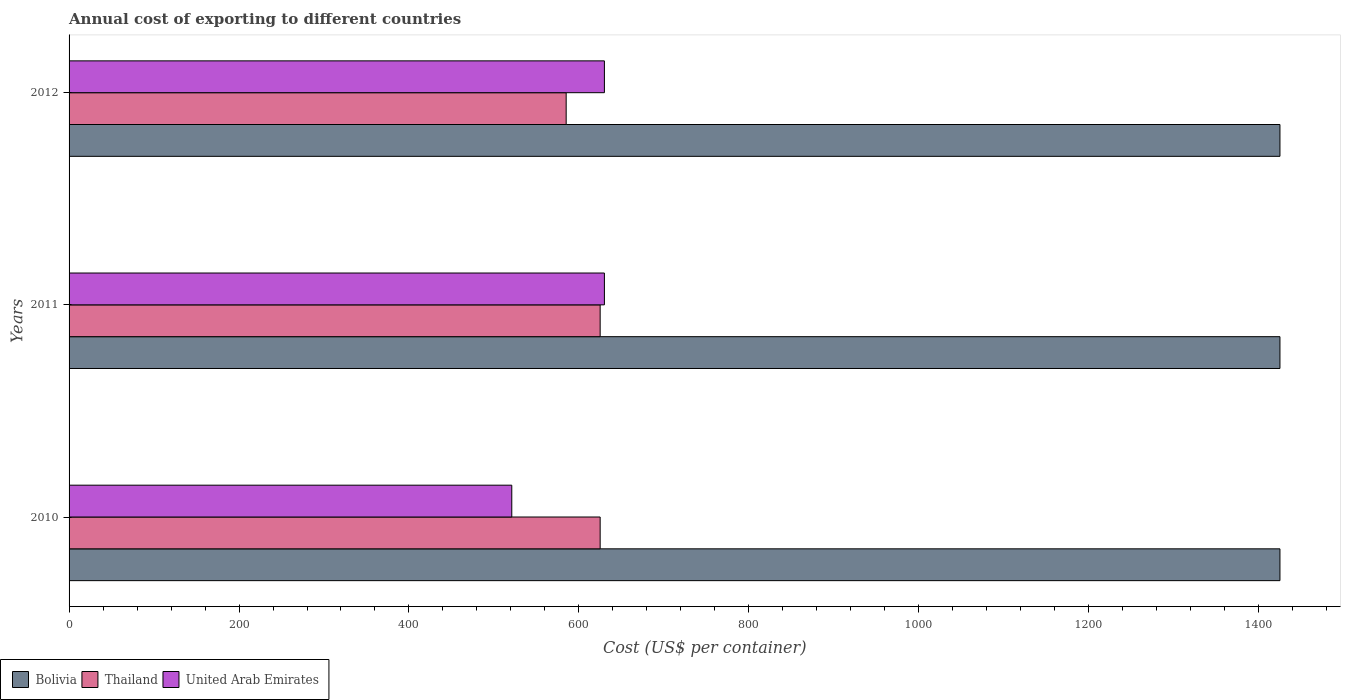How many groups of bars are there?
Keep it short and to the point. 3. Are the number of bars per tick equal to the number of legend labels?
Keep it short and to the point. Yes. How many bars are there on the 3rd tick from the top?
Offer a terse response. 3. How many bars are there on the 2nd tick from the bottom?
Your answer should be very brief. 3. In how many cases, is the number of bars for a given year not equal to the number of legend labels?
Your response must be concise. 0. What is the total annual cost of exporting in Bolivia in 2010?
Your response must be concise. 1425. Across all years, what is the maximum total annual cost of exporting in United Arab Emirates?
Give a very brief answer. 630. Across all years, what is the minimum total annual cost of exporting in Thailand?
Your answer should be compact. 585. In which year was the total annual cost of exporting in Bolivia maximum?
Offer a terse response. 2010. In which year was the total annual cost of exporting in Bolivia minimum?
Ensure brevity in your answer.  2010. What is the total total annual cost of exporting in Thailand in the graph?
Give a very brief answer. 1835. What is the difference between the total annual cost of exporting in Thailand in 2011 and that in 2012?
Your answer should be compact. 40. What is the difference between the total annual cost of exporting in United Arab Emirates in 2011 and the total annual cost of exporting in Thailand in 2012?
Your answer should be compact. 45. What is the average total annual cost of exporting in Bolivia per year?
Provide a short and direct response. 1425. In the year 2010, what is the difference between the total annual cost of exporting in Thailand and total annual cost of exporting in Bolivia?
Your response must be concise. -800. What is the difference between the highest and the lowest total annual cost of exporting in United Arab Emirates?
Keep it short and to the point. 109. In how many years, is the total annual cost of exporting in Thailand greater than the average total annual cost of exporting in Thailand taken over all years?
Your response must be concise. 2. Is the sum of the total annual cost of exporting in Bolivia in 2010 and 2011 greater than the maximum total annual cost of exporting in Thailand across all years?
Make the answer very short. Yes. What does the 2nd bar from the top in 2011 represents?
Your answer should be compact. Thailand. What does the 2nd bar from the bottom in 2012 represents?
Give a very brief answer. Thailand. How many years are there in the graph?
Your answer should be very brief. 3. What is the difference between two consecutive major ticks on the X-axis?
Your answer should be compact. 200. Does the graph contain grids?
Ensure brevity in your answer.  No. What is the title of the graph?
Provide a short and direct response. Annual cost of exporting to different countries. What is the label or title of the X-axis?
Keep it short and to the point. Cost (US$ per container). What is the label or title of the Y-axis?
Offer a very short reply. Years. What is the Cost (US$ per container) of Bolivia in 2010?
Ensure brevity in your answer.  1425. What is the Cost (US$ per container) in Thailand in 2010?
Offer a terse response. 625. What is the Cost (US$ per container) of United Arab Emirates in 2010?
Offer a very short reply. 521. What is the Cost (US$ per container) of Bolivia in 2011?
Offer a terse response. 1425. What is the Cost (US$ per container) in Thailand in 2011?
Your answer should be very brief. 625. What is the Cost (US$ per container) of United Arab Emirates in 2011?
Make the answer very short. 630. What is the Cost (US$ per container) of Bolivia in 2012?
Offer a terse response. 1425. What is the Cost (US$ per container) of Thailand in 2012?
Ensure brevity in your answer.  585. What is the Cost (US$ per container) of United Arab Emirates in 2012?
Offer a terse response. 630. Across all years, what is the maximum Cost (US$ per container) of Bolivia?
Your response must be concise. 1425. Across all years, what is the maximum Cost (US$ per container) in Thailand?
Ensure brevity in your answer.  625. Across all years, what is the maximum Cost (US$ per container) of United Arab Emirates?
Provide a short and direct response. 630. Across all years, what is the minimum Cost (US$ per container) of Bolivia?
Give a very brief answer. 1425. Across all years, what is the minimum Cost (US$ per container) in Thailand?
Give a very brief answer. 585. Across all years, what is the minimum Cost (US$ per container) in United Arab Emirates?
Offer a very short reply. 521. What is the total Cost (US$ per container) of Bolivia in the graph?
Ensure brevity in your answer.  4275. What is the total Cost (US$ per container) of Thailand in the graph?
Provide a short and direct response. 1835. What is the total Cost (US$ per container) of United Arab Emirates in the graph?
Provide a succinct answer. 1781. What is the difference between the Cost (US$ per container) of Bolivia in 2010 and that in 2011?
Provide a succinct answer. 0. What is the difference between the Cost (US$ per container) of Thailand in 2010 and that in 2011?
Offer a very short reply. 0. What is the difference between the Cost (US$ per container) in United Arab Emirates in 2010 and that in 2011?
Give a very brief answer. -109. What is the difference between the Cost (US$ per container) in United Arab Emirates in 2010 and that in 2012?
Make the answer very short. -109. What is the difference between the Cost (US$ per container) of Thailand in 2011 and that in 2012?
Make the answer very short. 40. What is the difference between the Cost (US$ per container) of United Arab Emirates in 2011 and that in 2012?
Make the answer very short. 0. What is the difference between the Cost (US$ per container) of Bolivia in 2010 and the Cost (US$ per container) of Thailand in 2011?
Keep it short and to the point. 800. What is the difference between the Cost (US$ per container) in Bolivia in 2010 and the Cost (US$ per container) in United Arab Emirates in 2011?
Your response must be concise. 795. What is the difference between the Cost (US$ per container) of Thailand in 2010 and the Cost (US$ per container) of United Arab Emirates in 2011?
Your answer should be very brief. -5. What is the difference between the Cost (US$ per container) of Bolivia in 2010 and the Cost (US$ per container) of Thailand in 2012?
Ensure brevity in your answer.  840. What is the difference between the Cost (US$ per container) in Bolivia in 2010 and the Cost (US$ per container) in United Arab Emirates in 2012?
Give a very brief answer. 795. What is the difference between the Cost (US$ per container) in Bolivia in 2011 and the Cost (US$ per container) in Thailand in 2012?
Keep it short and to the point. 840. What is the difference between the Cost (US$ per container) of Bolivia in 2011 and the Cost (US$ per container) of United Arab Emirates in 2012?
Offer a very short reply. 795. What is the average Cost (US$ per container) of Bolivia per year?
Offer a very short reply. 1425. What is the average Cost (US$ per container) in Thailand per year?
Your response must be concise. 611.67. What is the average Cost (US$ per container) in United Arab Emirates per year?
Provide a succinct answer. 593.67. In the year 2010, what is the difference between the Cost (US$ per container) in Bolivia and Cost (US$ per container) in Thailand?
Your answer should be compact. 800. In the year 2010, what is the difference between the Cost (US$ per container) of Bolivia and Cost (US$ per container) of United Arab Emirates?
Give a very brief answer. 904. In the year 2010, what is the difference between the Cost (US$ per container) in Thailand and Cost (US$ per container) in United Arab Emirates?
Your answer should be very brief. 104. In the year 2011, what is the difference between the Cost (US$ per container) in Bolivia and Cost (US$ per container) in Thailand?
Your answer should be compact. 800. In the year 2011, what is the difference between the Cost (US$ per container) in Bolivia and Cost (US$ per container) in United Arab Emirates?
Provide a succinct answer. 795. In the year 2012, what is the difference between the Cost (US$ per container) of Bolivia and Cost (US$ per container) of Thailand?
Your answer should be very brief. 840. In the year 2012, what is the difference between the Cost (US$ per container) in Bolivia and Cost (US$ per container) in United Arab Emirates?
Provide a short and direct response. 795. In the year 2012, what is the difference between the Cost (US$ per container) of Thailand and Cost (US$ per container) of United Arab Emirates?
Offer a very short reply. -45. What is the ratio of the Cost (US$ per container) of Bolivia in 2010 to that in 2011?
Make the answer very short. 1. What is the ratio of the Cost (US$ per container) in Thailand in 2010 to that in 2011?
Your response must be concise. 1. What is the ratio of the Cost (US$ per container) of United Arab Emirates in 2010 to that in 2011?
Provide a short and direct response. 0.83. What is the ratio of the Cost (US$ per container) of Bolivia in 2010 to that in 2012?
Keep it short and to the point. 1. What is the ratio of the Cost (US$ per container) in Thailand in 2010 to that in 2012?
Keep it short and to the point. 1.07. What is the ratio of the Cost (US$ per container) in United Arab Emirates in 2010 to that in 2012?
Provide a short and direct response. 0.83. What is the ratio of the Cost (US$ per container) in Thailand in 2011 to that in 2012?
Offer a terse response. 1.07. What is the difference between the highest and the second highest Cost (US$ per container) in United Arab Emirates?
Keep it short and to the point. 0. What is the difference between the highest and the lowest Cost (US$ per container) of Bolivia?
Your answer should be very brief. 0. What is the difference between the highest and the lowest Cost (US$ per container) in United Arab Emirates?
Ensure brevity in your answer.  109. 